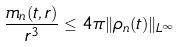<formula> <loc_0><loc_0><loc_500><loc_500>\frac { m _ { n } ( t , r ) } { r ^ { 3 } } \leq 4 \pi \| \rho _ { n } ( t ) \| _ { L ^ { \infty } }</formula> 